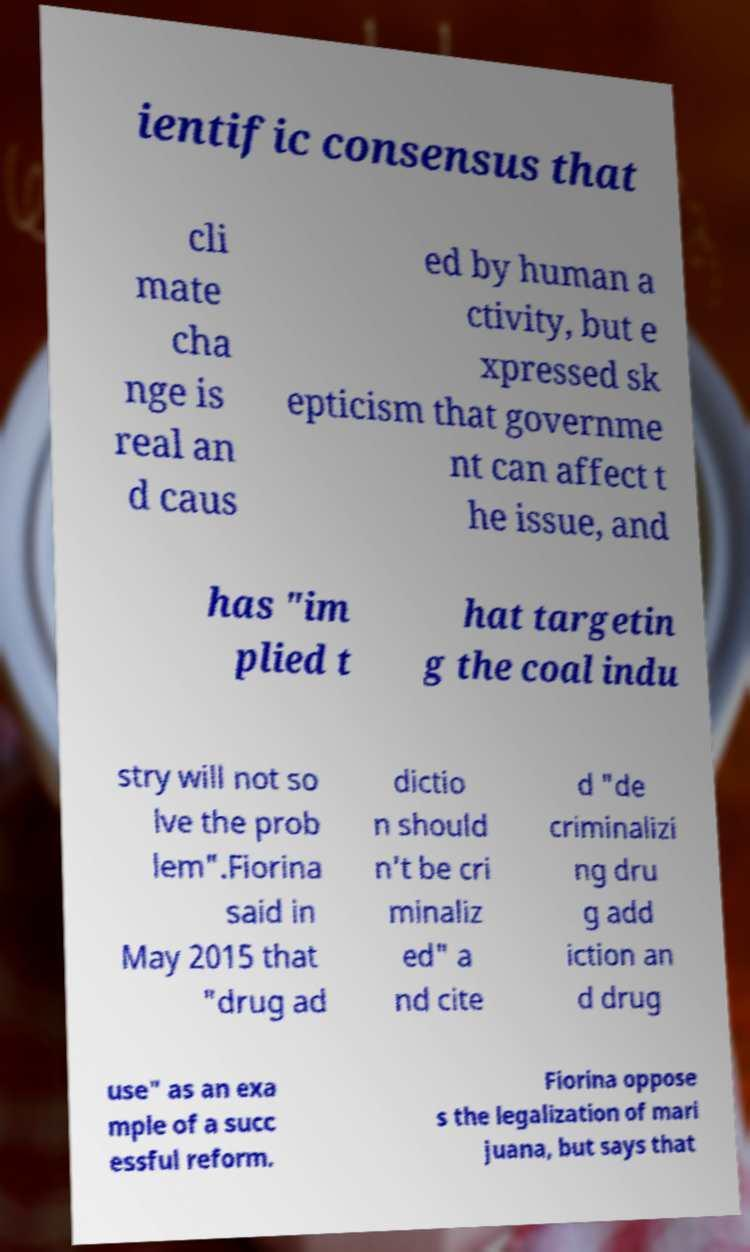Please read and relay the text visible in this image. What does it say? ientific consensus that cli mate cha nge is real an d caus ed by human a ctivity, but e xpressed sk epticism that governme nt can affect t he issue, and has "im plied t hat targetin g the coal indu stry will not so lve the prob lem".Fiorina said in May 2015 that "drug ad dictio n should n't be cri minaliz ed" a nd cite d "de criminalizi ng dru g add iction an d drug use" as an exa mple of a succ essful reform. Fiorina oppose s the legalization of mari juana, but says that 